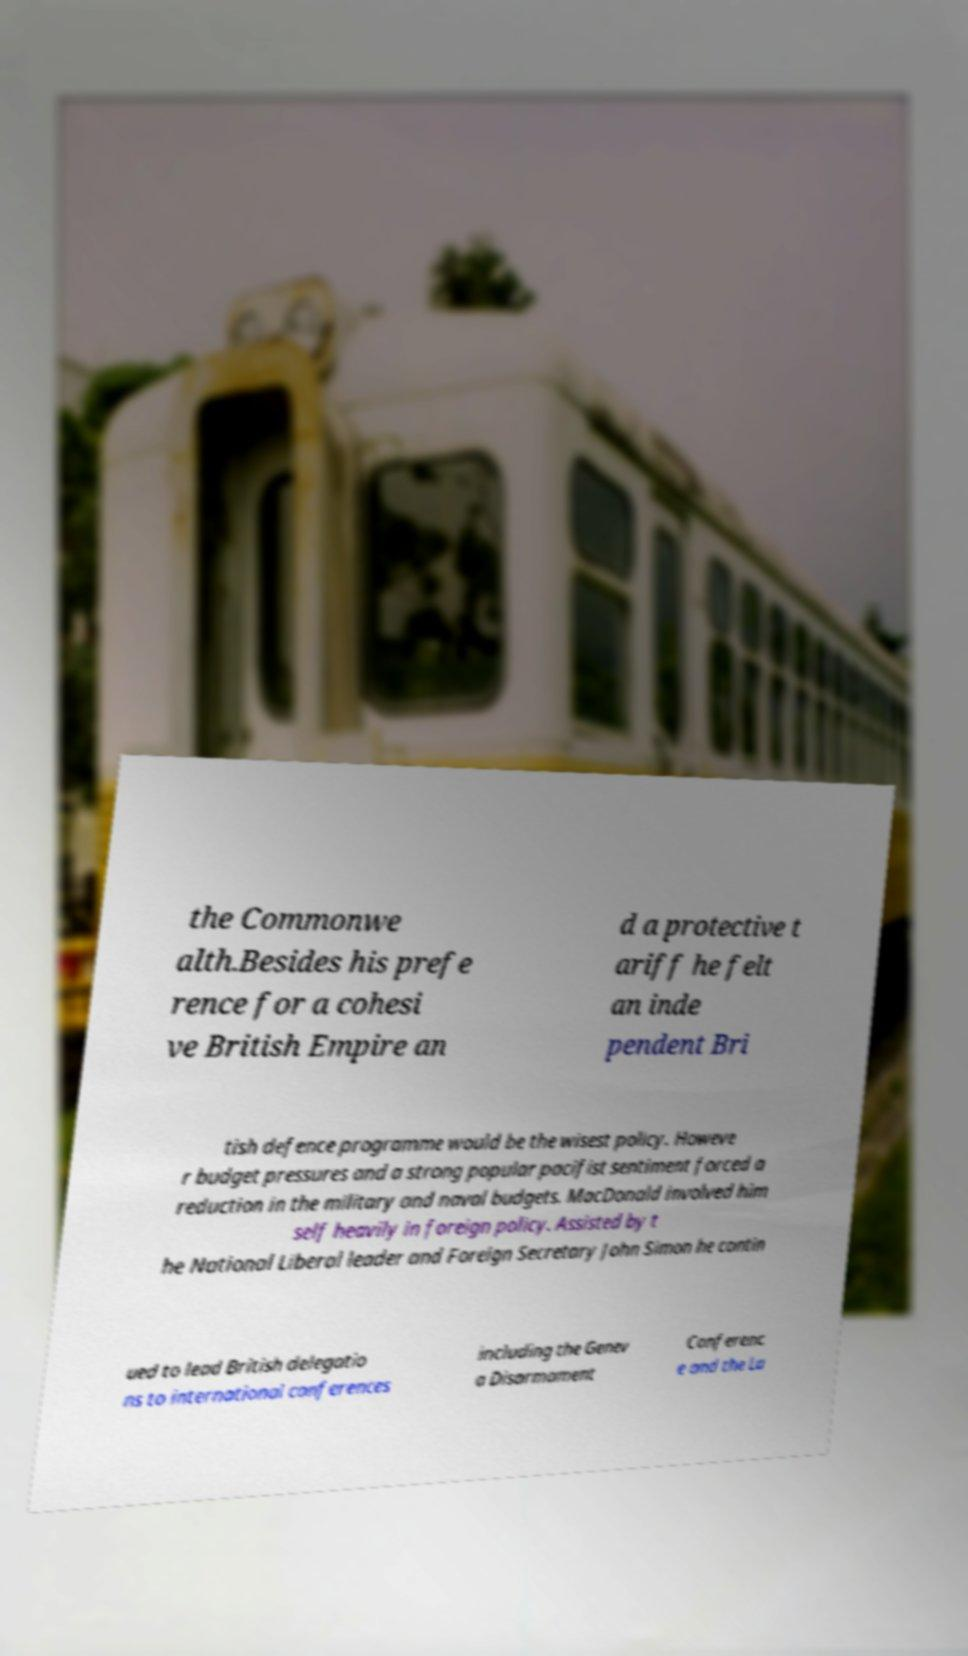Could you assist in decoding the text presented in this image and type it out clearly? the Commonwe alth.Besides his prefe rence for a cohesi ve British Empire an d a protective t ariff he felt an inde pendent Bri tish defence programme would be the wisest policy. Howeve r budget pressures and a strong popular pacifist sentiment forced a reduction in the military and naval budgets. MacDonald involved him self heavily in foreign policy. Assisted by t he National Liberal leader and Foreign Secretary John Simon he contin ued to lead British delegatio ns to international conferences including the Genev a Disarmament Conferenc e and the La 